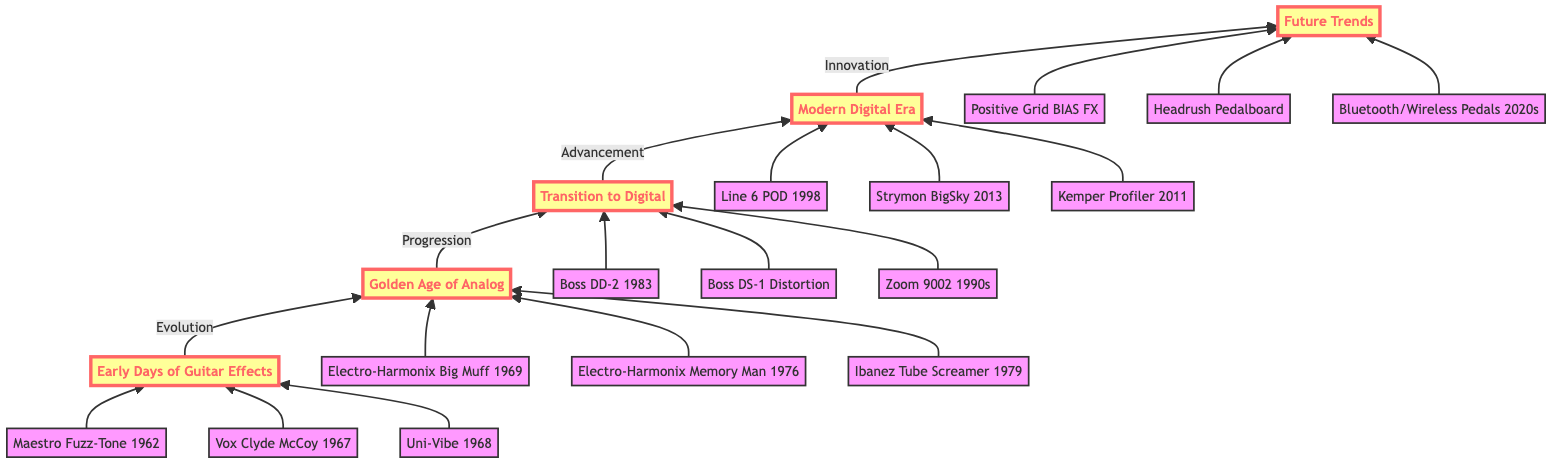What is the first node in the flow chart? The first node in the flow chart is "Early Days of Guitar Effects," indicating the starting point of the evolution journey.
Answer: Early Days of Guitar Effects How many key points are listed under "Golden Age of Analog"? The node "Golden Age of Analog" has three key points listed underneath it, which detail significant contributions during that era.
Answer: 3 What type of pedals were represented in the "Modern Digital Era"? The "Modern Digital Era" node includes sophisticated and innovative pedals, specifically highlighting digital advancements and multi-effects systems.
Answer: Digital pedals Which node directly follows the "Transition to Digital"? According to the flow direction, the node that follows "Transition to Digital" is "Modern Digital Era," showcasing advancements that followed the digital transition.
Answer: Modern Digital Era List one of the innovative features found in the "Future Trends" node. The "Future Trends" node includes features such as the integration of mobile apps for equipment customization, representing the continued evolution of guitar technology.
Answer: Mobile apps What significant pedal was introduced in 1983? The important pedal noted in the "Transition to Digital" section for its debut year is the "Boss DD-2," marking the introduction of digital delay technology.
Answer: Boss DD-2 How does "Golden Age of Analog" relate to "Early Days of Guitar Effects"? The relationship is that "Golden Age of Analog" follows directly from "Early Days of Guitar Effects," indicating a progression in the development of effects pedals over time.
Answer: Progression What technology began emerging in pedals during the 2020s? The "Future Trends" node mentions the incorporation of Bluetooth and wireless technology in pedals, highlighting a significant trend in this period.
Answer: Bluetooth and wireless technology How many total nodes are there in the flow chart? By counting all the nodes including the main eras and significant pedals, there are 15 distinct nodes in this flow chart.
Answer: 15 